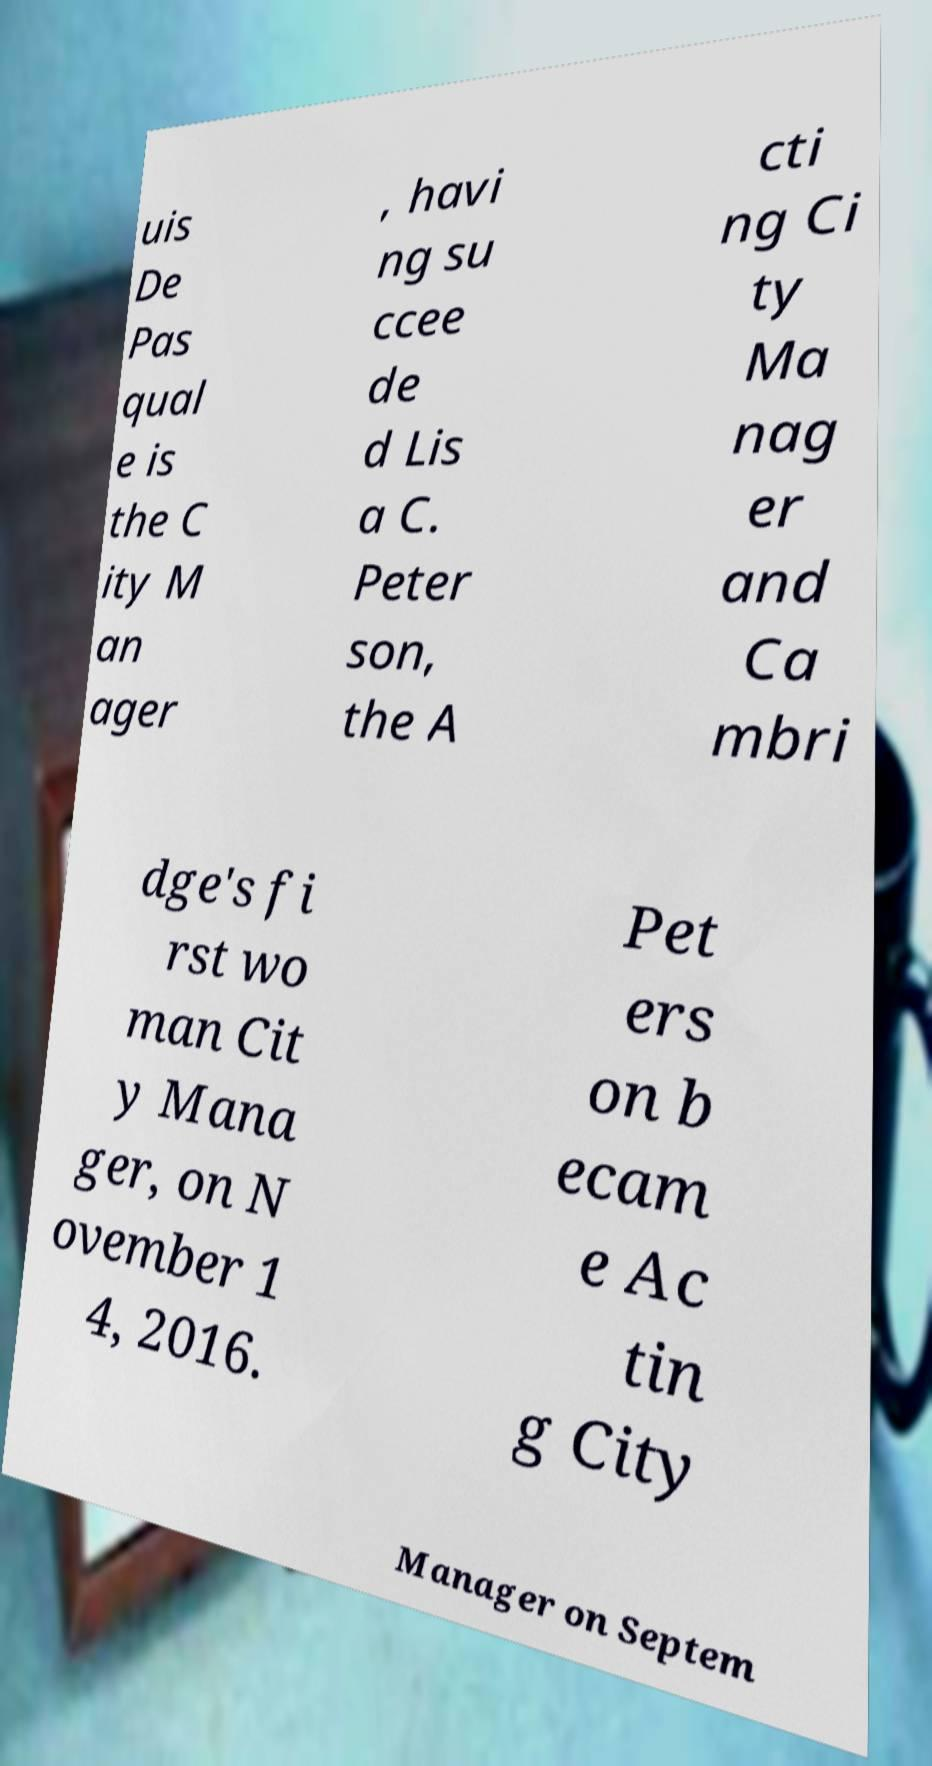Please identify and transcribe the text found in this image. uis De Pas qual e is the C ity M an ager , havi ng su ccee de d Lis a C. Peter son, the A cti ng Ci ty Ma nag er and Ca mbri dge's fi rst wo man Cit y Mana ger, on N ovember 1 4, 2016. Pet ers on b ecam e Ac tin g City Manager on Septem 